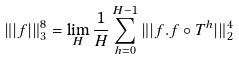<formula> <loc_0><loc_0><loc_500><loc_500>\| | f | \| _ { 3 } ^ { 8 } = \lim _ { H } \frac { 1 } { H } \sum _ { h = 0 } ^ { H - 1 } \| | f . f \circ T ^ { h } | \| _ { 2 } ^ { 4 }</formula> 